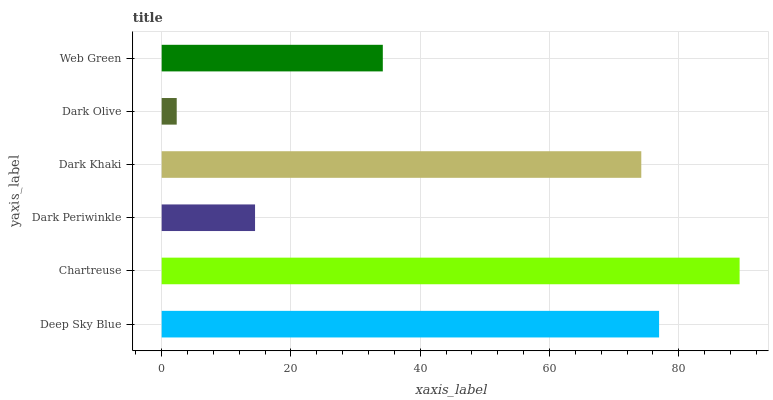Is Dark Olive the minimum?
Answer yes or no. Yes. Is Chartreuse the maximum?
Answer yes or no. Yes. Is Dark Periwinkle the minimum?
Answer yes or no. No. Is Dark Periwinkle the maximum?
Answer yes or no. No. Is Chartreuse greater than Dark Periwinkle?
Answer yes or no. Yes. Is Dark Periwinkle less than Chartreuse?
Answer yes or no. Yes. Is Dark Periwinkle greater than Chartreuse?
Answer yes or no. No. Is Chartreuse less than Dark Periwinkle?
Answer yes or no. No. Is Dark Khaki the high median?
Answer yes or no. Yes. Is Web Green the low median?
Answer yes or no. Yes. Is Dark Olive the high median?
Answer yes or no. No. Is Dark Periwinkle the low median?
Answer yes or no. No. 